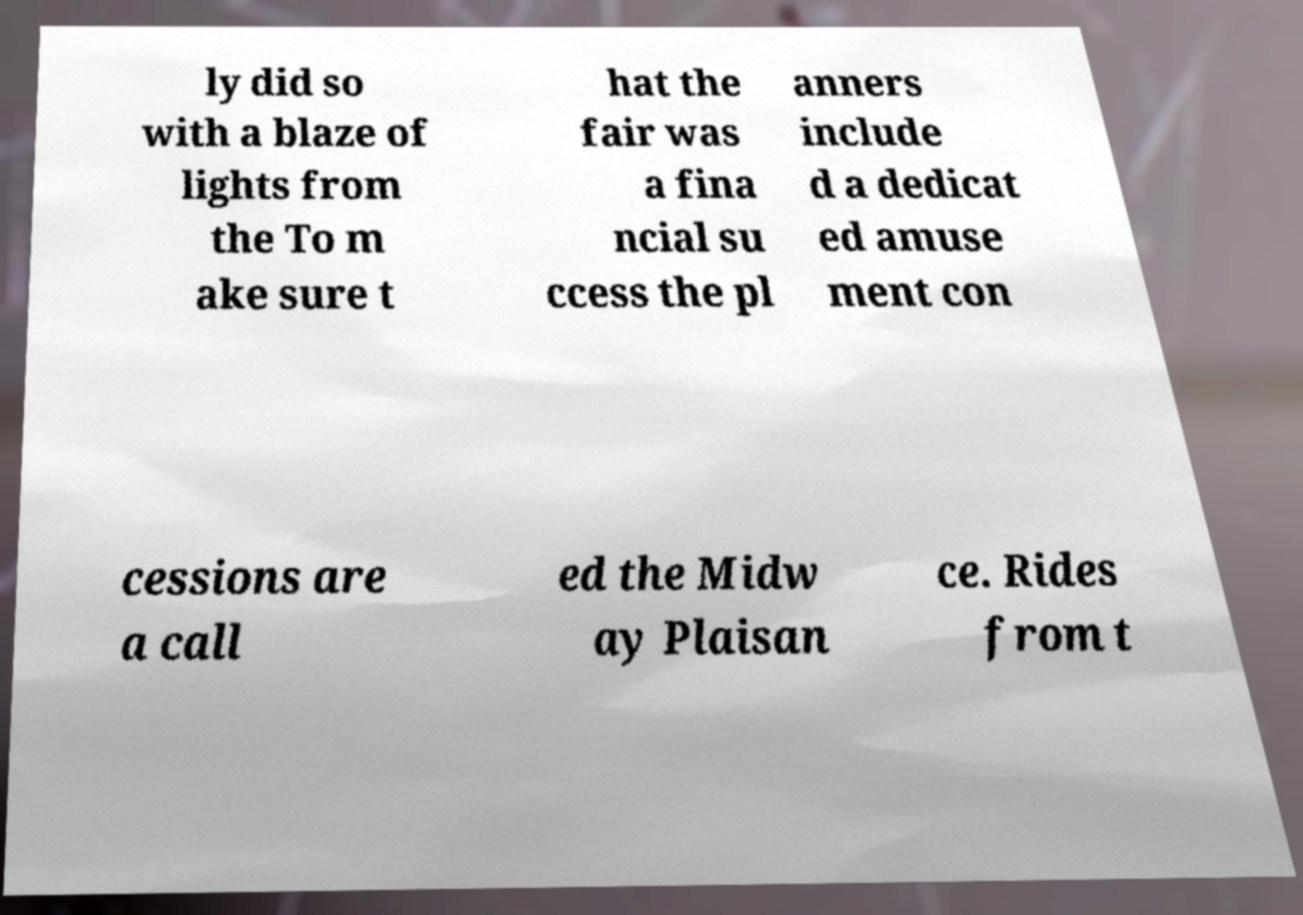What messages or text are displayed in this image? I need them in a readable, typed format. ly did so with a blaze of lights from the To m ake sure t hat the fair was a fina ncial su ccess the pl anners include d a dedicat ed amuse ment con cessions are a call ed the Midw ay Plaisan ce. Rides from t 